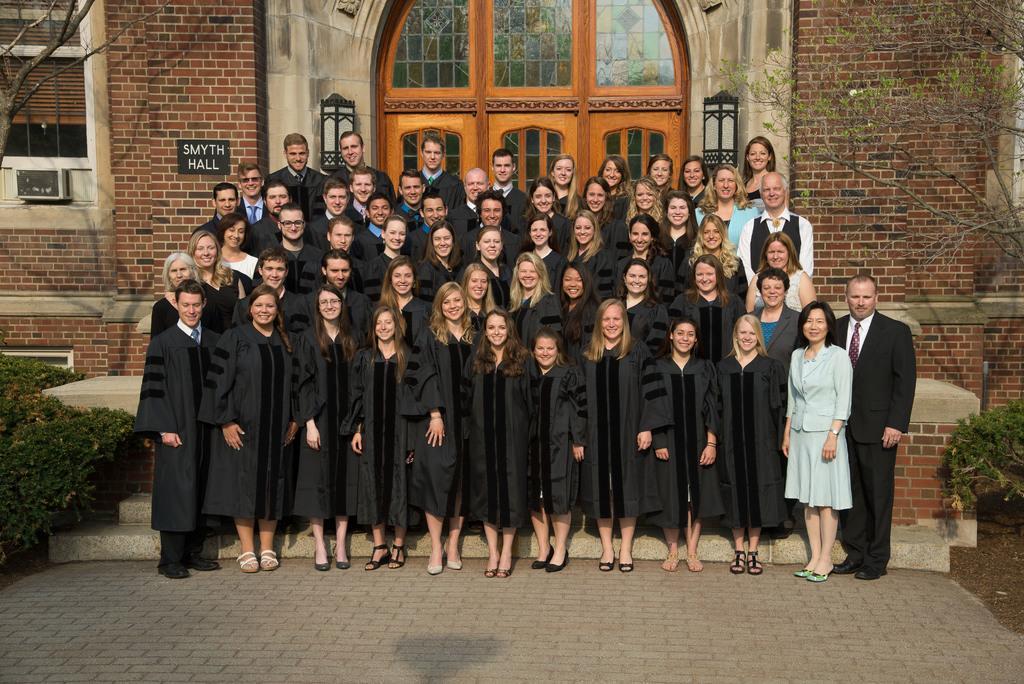Please provide a concise description of this image. In this picture we can see a group of people standing and smiling, trees and in the background we can see a building, name board, windows. 